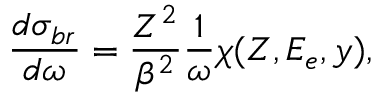<formula> <loc_0><loc_0><loc_500><loc_500>\frac { d \sigma _ { b r } } { d \omega } = \frac { Z ^ { 2 } } { \beta ^ { 2 } } \frac { 1 } { \omega } \chi ( Z , E _ { e } , y ) ,</formula> 